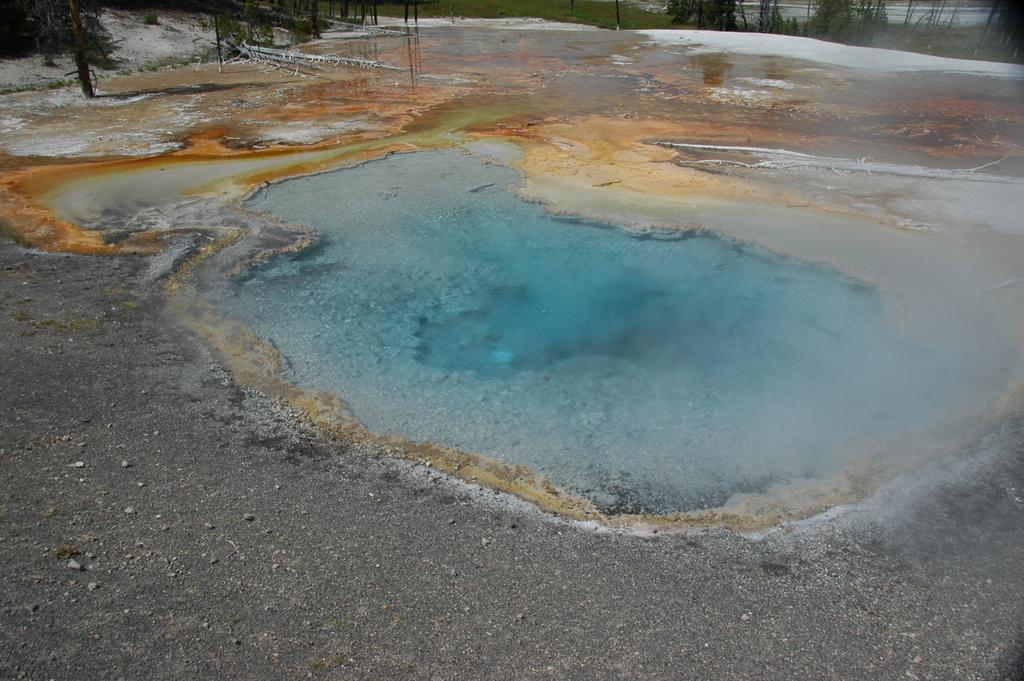What is visible in the image? There is water and trees visible in the image. Can you describe the water in the image? The water is visible, but its specific characteristics are not mentioned in the facts. What type of vegetation is present in the image? Trees are present in the image. What color is the feather floating on the water in the image? There is no feather present in the image. Is the water poisonous in the image? The facts do not mention anything about the water being poisonous, so we cannot determine that from the image. 